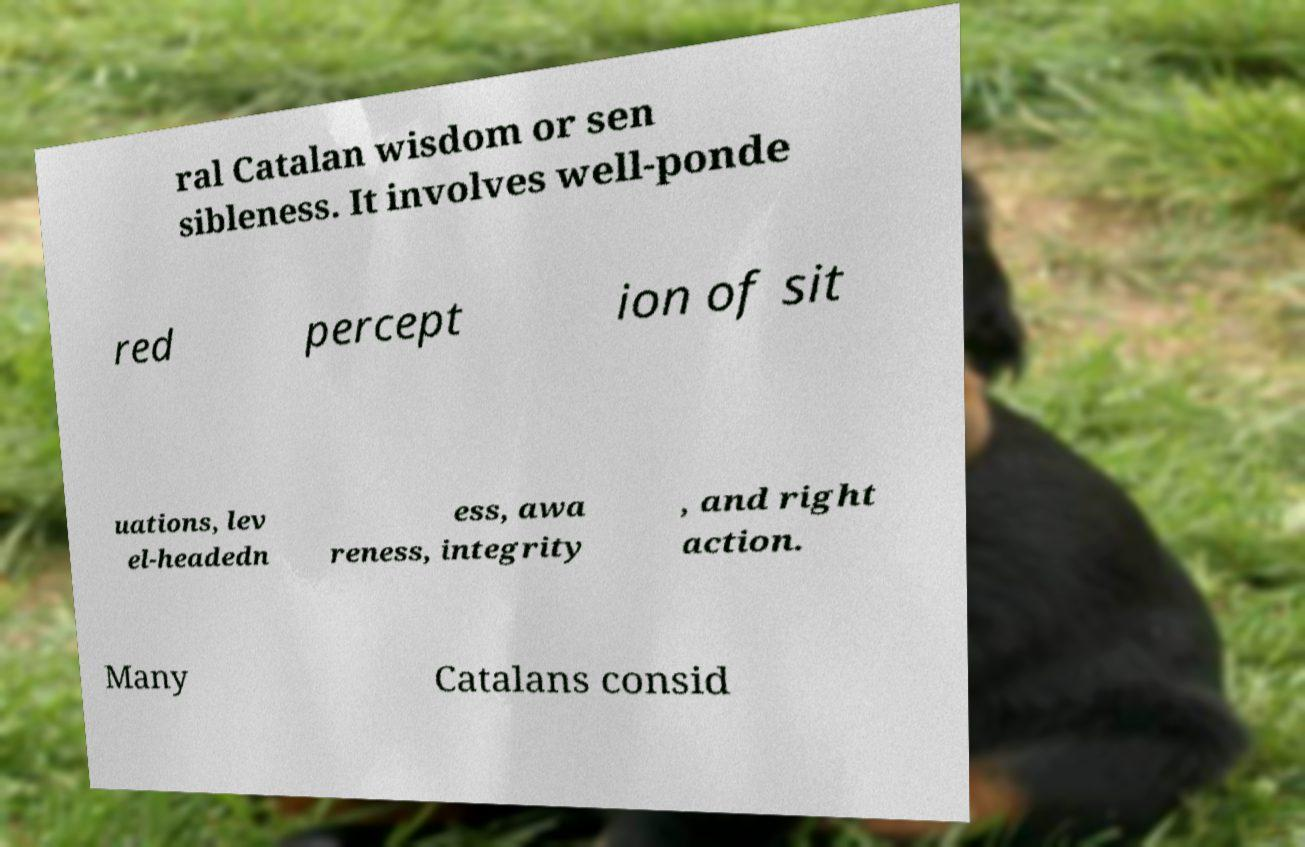Could you extract and type out the text from this image? ral Catalan wisdom or sen sibleness. It involves well-ponde red percept ion of sit uations, lev el-headedn ess, awa reness, integrity , and right action. Many Catalans consid 